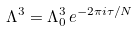<formula> <loc_0><loc_0><loc_500><loc_500>\Lambda ^ { 3 } = \Lambda _ { 0 } ^ { 3 } \, e ^ { - 2 \pi i \tau / N }</formula> 